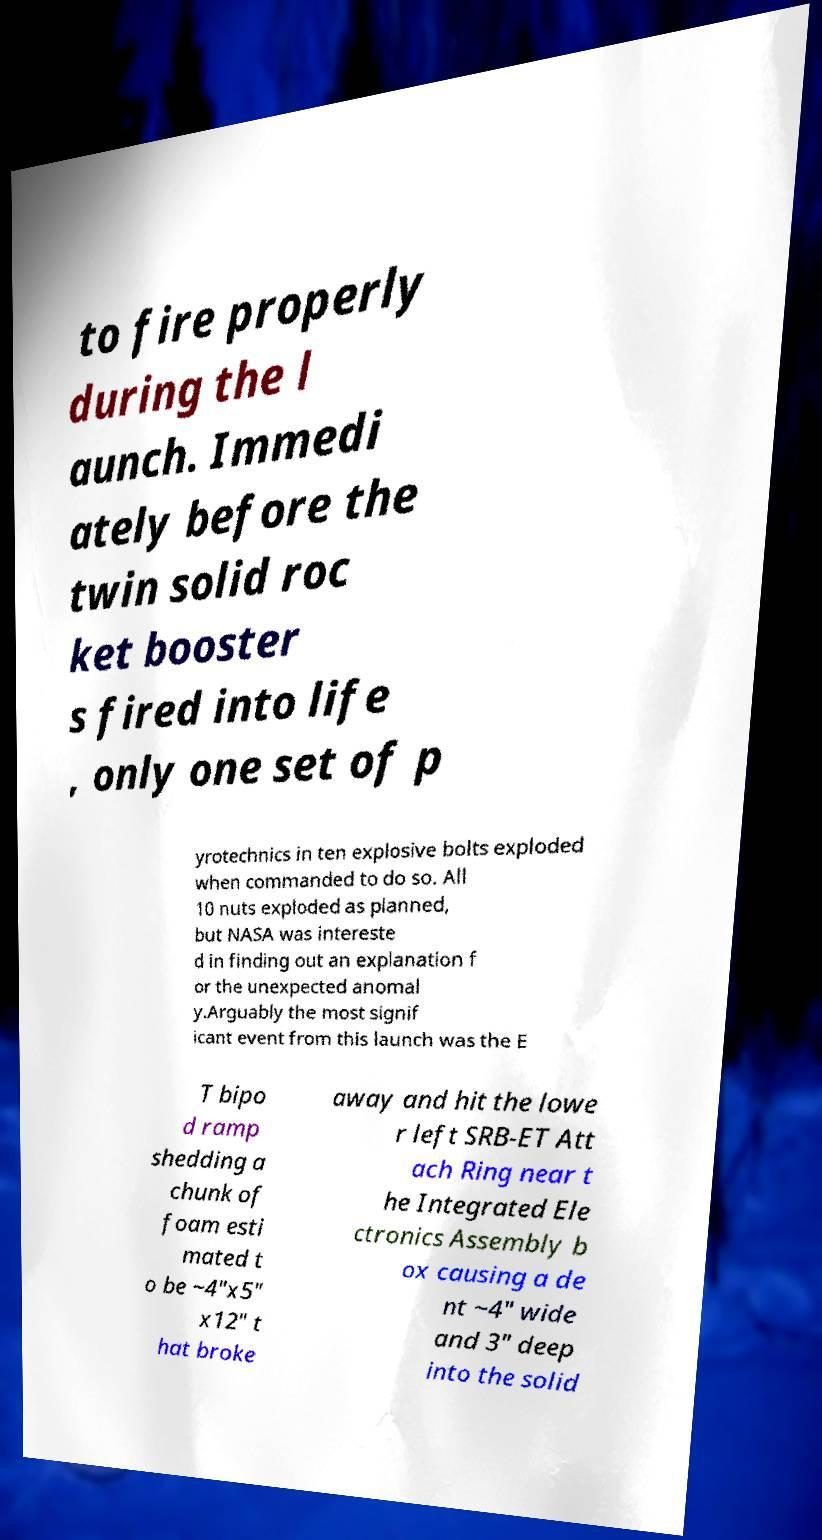Can you accurately transcribe the text from the provided image for me? to fire properly during the l aunch. Immedi ately before the twin solid roc ket booster s fired into life , only one set of p yrotechnics in ten explosive bolts exploded when commanded to do so. All 10 nuts exploded as planned, but NASA was intereste d in finding out an explanation f or the unexpected anomal y.Arguably the most signif icant event from this launch was the E T bipo d ramp shedding a chunk of foam esti mated t o be ~4"x5" x12" t hat broke away and hit the lowe r left SRB-ET Att ach Ring near t he Integrated Ele ctronics Assembly b ox causing a de nt ~4" wide and 3" deep into the solid 